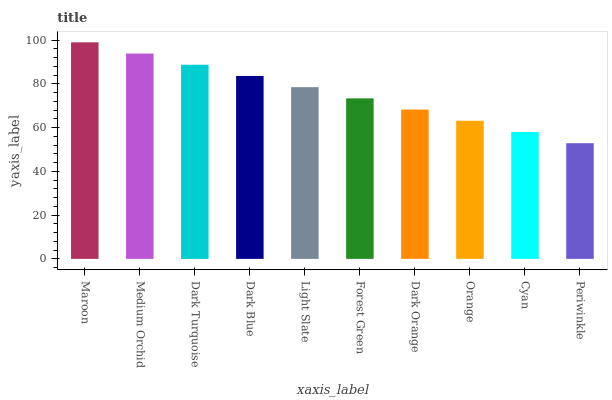Is Medium Orchid the minimum?
Answer yes or no. No. Is Medium Orchid the maximum?
Answer yes or no. No. Is Maroon greater than Medium Orchid?
Answer yes or no. Yes. Is Medium Orchid less than Maroon?
Answer yes or no. Yes. Is Medium Orchid greater than Maroon?
Answer yes or no. No. Is Maroon less than Medium Orchid?
Answer yes or no. No. Is Light Slate the high median?
Answer yes or no. Yes. Is Forest Green the low median?
Answer yes or no. Yes. Is Periwinkle the high median?
Answer yes or no. No. Is Light Slate the low median?
Answer yes or no. No. 